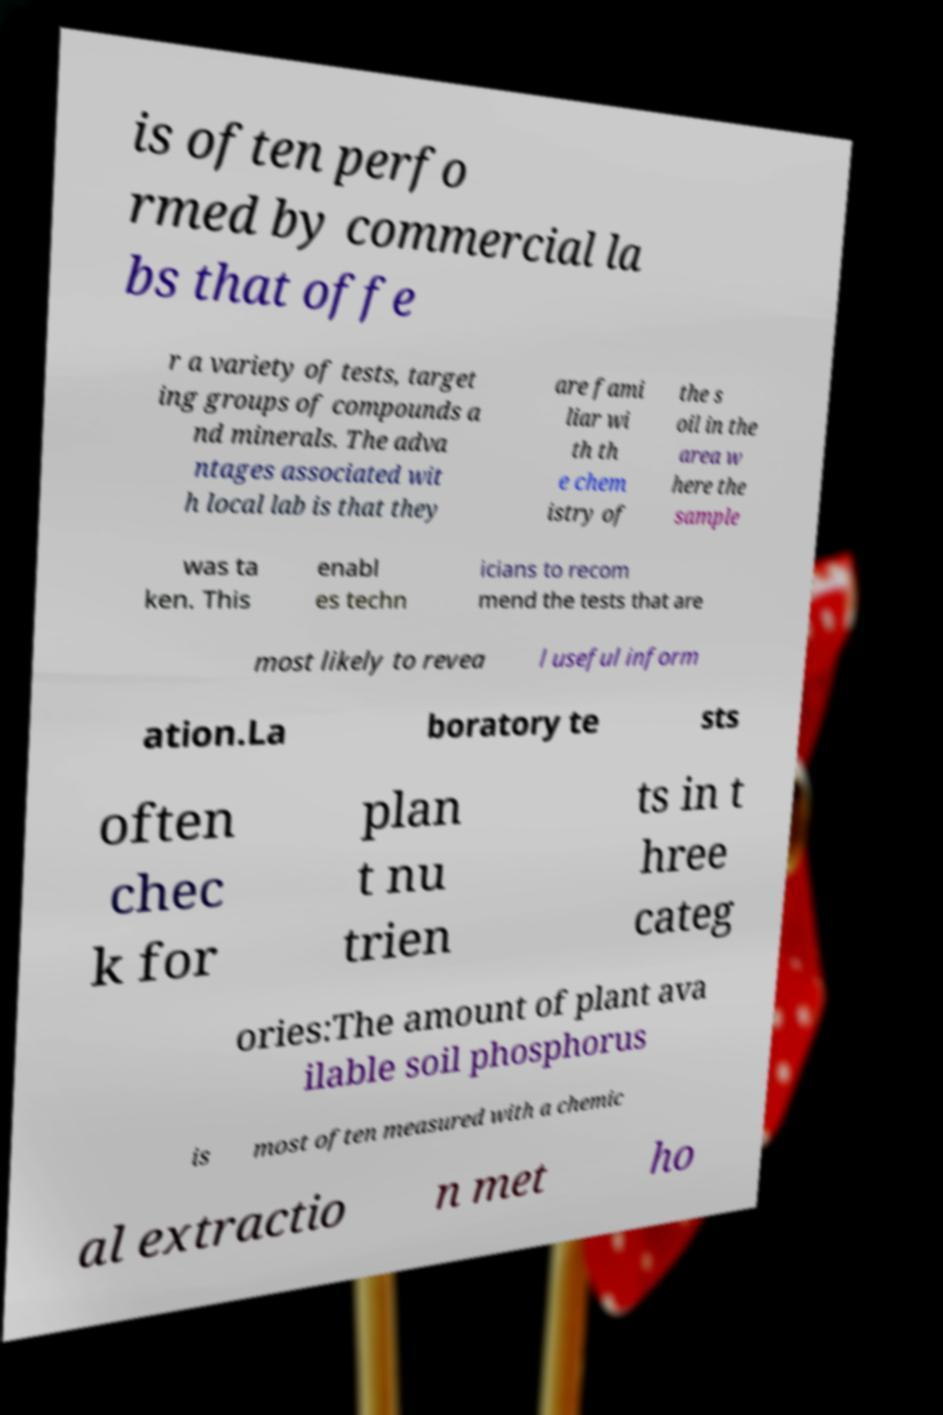Can you accurately transcribe the text from the provided image for me? is often perfo rmed by commercial la bs that offe r a variety of tests, target ing groups of compounds a nd minerals. The adva ntages associated wit h local lab is that they are fami liar wi th th e chem istry of the s oil in the area w here the sample was ta ken. This enabl es techn icians to recom mend the tests that are most likely to revea l useful inform ation.La boratory te sts often chec k for plan t nu trien ts in t hree categ ories:The amount of plant ava ilable soil phosphorus is most often measured with a chemic al extractio n met ho 